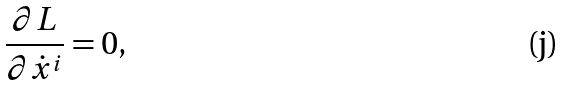Convert formula to latex. <formula><loc_0><loc_0><loc_500><loc_500>\frac { \partial L } { \partial \dot { x } ^ { i } } = 0 ,</formula> 